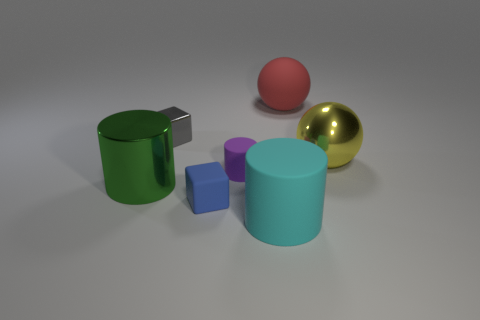Add 1 gray blocks. How many objects exist? 8 Subtract all cylinders. How many objects are left? 4 Subtract all big metal balls. Subtract all tiny gray metal blocks. How many objects are left? 5 Add 6 spheres. How many spheres are left? 8 Add 7 big matte cylinders. How many big matte cylinders exist? 8 Subtract 0 gray cylinders. How many objects are left? 7 